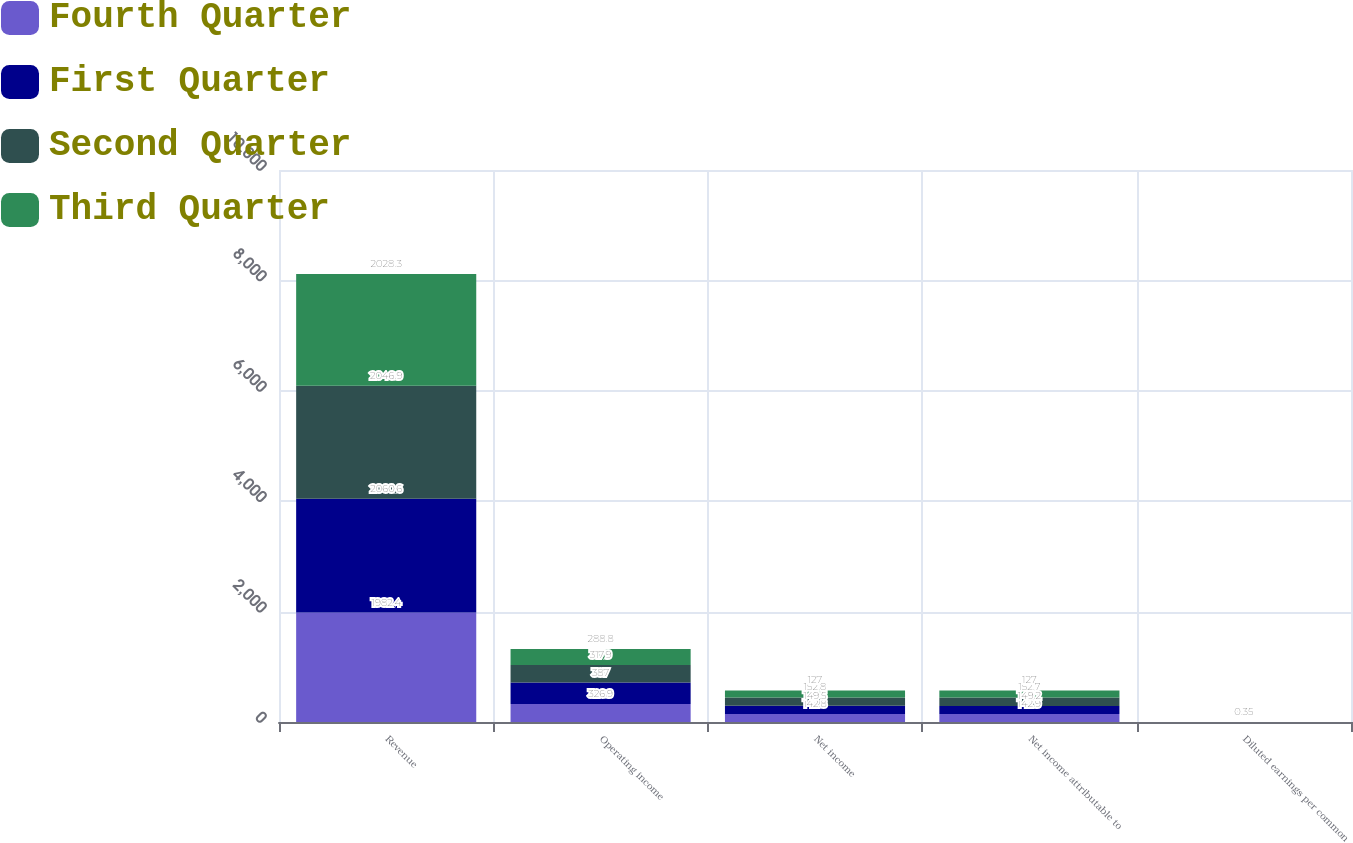<chart> <loc_0><loc_0><loc_500><loc_500><stacked_bar_chart><ecel><fcel>Revenue<fcel>Operating income<fcel>Net income<fcel>Net income attributable to<fcel>Diluted earnings per common<nl><fcel>Fourth Quarter<fcel>1982.4<fcel>326.9<fcel>142.8<fcel>142.9<fcel>0.38<nl><fcel>First Quarter<fcel>2060.6<fcel>387<fcel>149.5<fcel>149.2<fcel>0.4<nl><fcel>Second Quarter<fcel>2046.9<fcel>317.9<fcel>152.8<fcel>152.7<fcel>0.42<nl><fcel>Third Quarter<fcel>2028.3<fcel>288.8<fcel>127<fcel>127<fcel>0.35<nl></chart> 